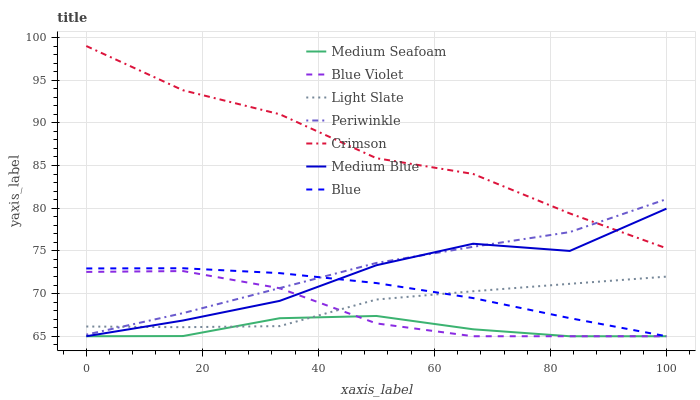Does Medium Seafoam have the minimum area under the curve?
Answer yes or no. Yes. Does Crimson have the maximum area under the curve?
Answer yes or no. Yes. Does Light Slate have the minimum area under the curve?
Answer yes or no. No. Does Light Slate have the maximum area under the curve?
Answer yes or no. No. Is Blue the smoothest?
Answer yes or no. Yes. Is Medium Blue the roughest?
Answer yes or no. Yes. Is Light Slate the smoothest?
Answer yes or no. No. Is Light Slate the roughest?
Answer yes or no. No. Does Blue have the lowest value?
Answer yes or no. Yes. Does Light Slate have the lowest value?
Answer yes or no. No. Does Crimson have the highest value?
Answer yes or no. Yes. Does Light Slate have the highest value?
Answer yes or no. No. Is Medium Seafoam less than Periwinkle?
Answer yes or no. Yes. Is Crimson greater than Blue?
Answer yes or no. Yes. Does Periwinkle intersect Blue Violet?
Answer yes or no. Yes. Is Periwinkle less than Blue Violet?
Answer yes or no. No. Is Periwinkle greater than Blue Violet?
Answer yes or no. No. Does Medium Seafoam intersect Periwinkle?
Answer yes or no. No. 